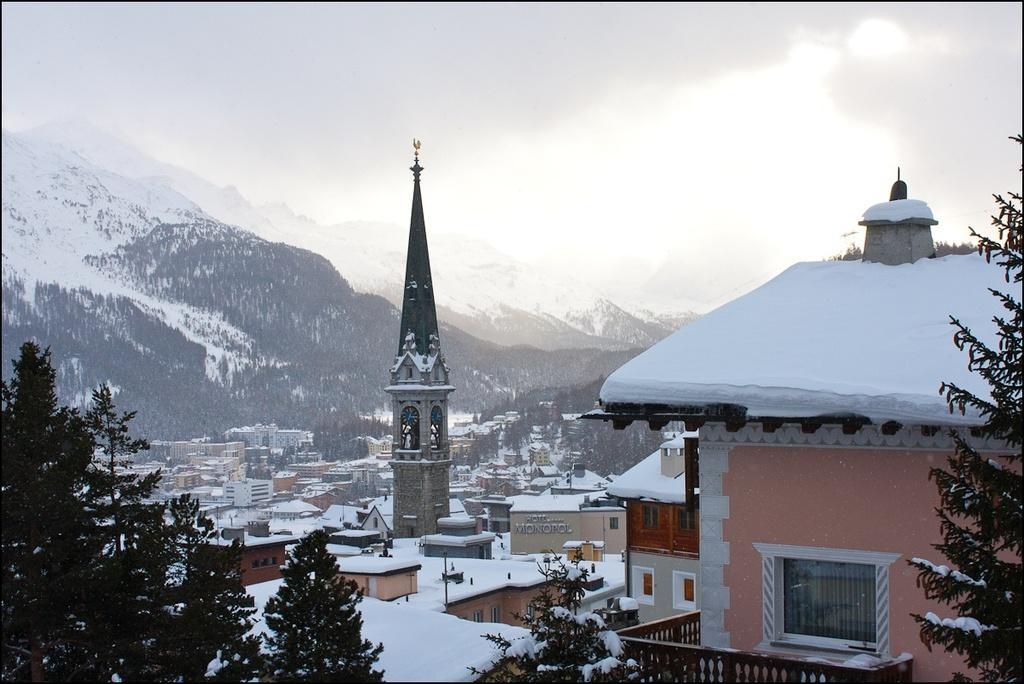What type of weather is depicted in the image? The image shows houses and mountains covered with snow, indicating that it is a snowy scene. What other natural elements can be seen in the image? There are trees in the image. What are the mountains in the image covered with? The mountains in the image are covered with snow. What can be seen above the houses and mountains in the image? The sky is visible in the image. Where is the toothpaste tube located in the image? There is no toothpaste tube present in the image. What type of curve can be seen in the image? There is no specific curve mentioned or depicted in the image. 